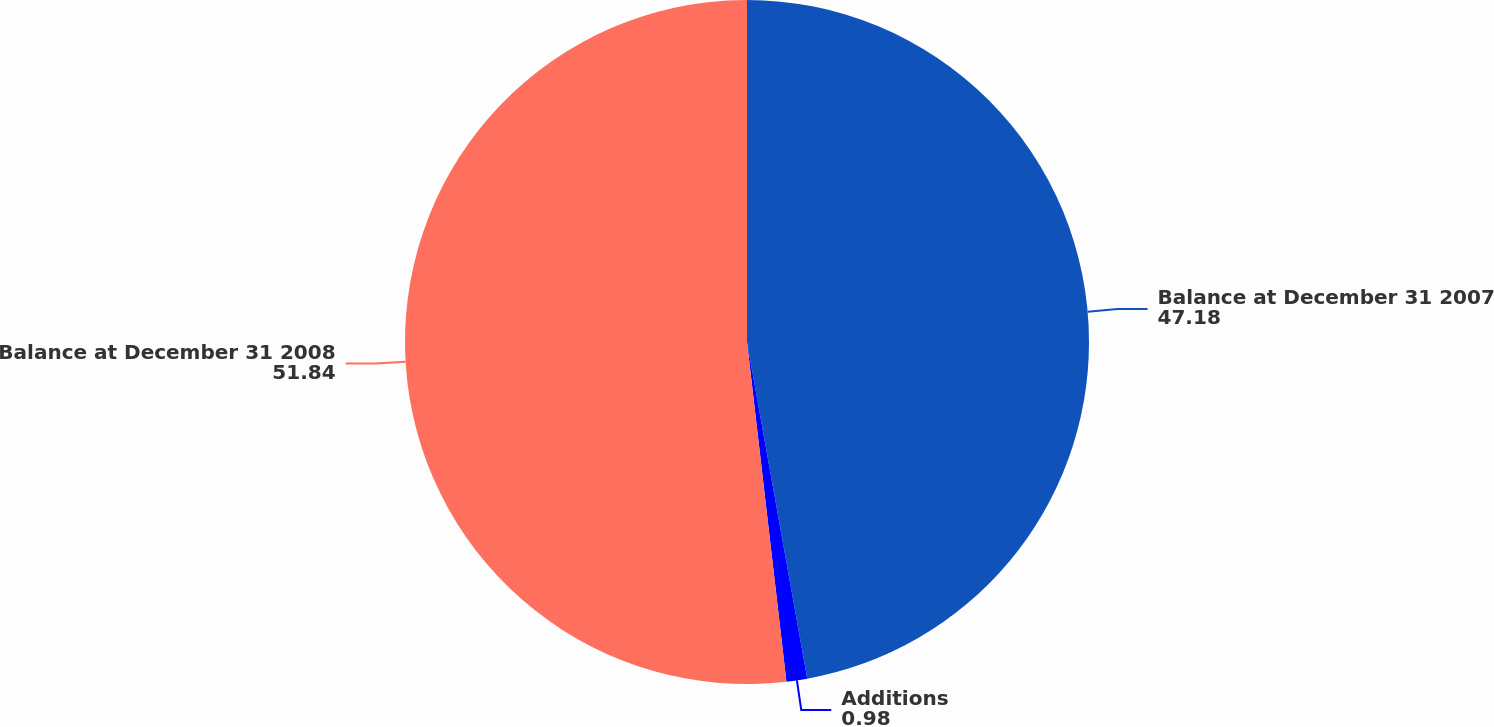Convert chart. <chart><loc_0><loc_0><loc_500><loc_500><pie_chart><fcel>Balance at December 31 2007<fcel>Additions<fcel>Balance at December 31 2008<nl><fcel>47.18%<fcel>0.98%<fcel>51.84%<nl></chart> 